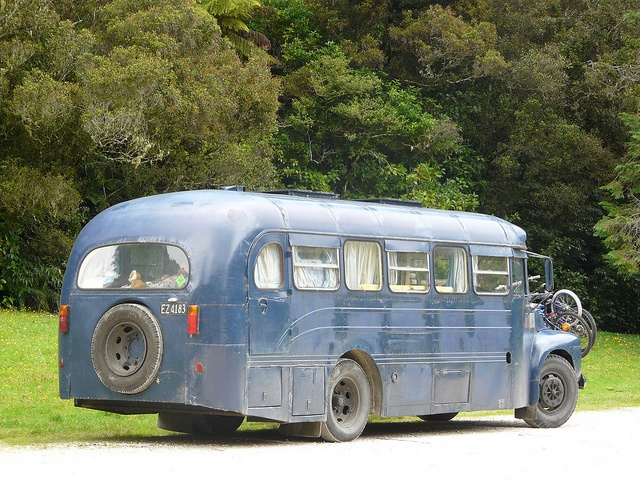Describe the objects in this image and their specific colors. I can see bus in olive, darkgray, gray, and lightgray tones, bicycle in olive, gray, darkgray, and black tones, bicycle in olive, gray, white, darkgray, and black tones, and bicycle in olive, gray, black, darkgray, and darkgreen tones in this image. 